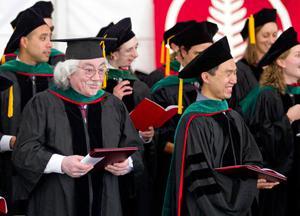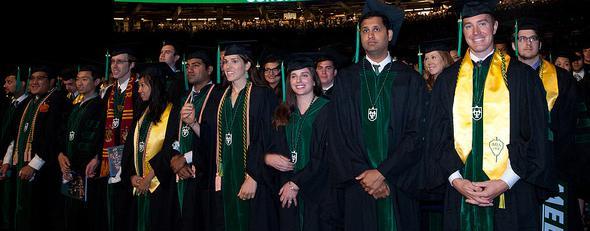The first image is the image on the left, the second image is the image on the right. Evaluate the accuracy of this statement regarding the images: "In one image, graduates are walking forward wearing black robes with green sleeve stripes and caps with green tassles.". Is it true? Answer yes or no. No. The first image is the image on the left, the second image is the image on the right. Examine the images to the left and right. Is the description "Blue seats are shown in the auditorium behind the graduates in one of the images." accurate? Answer yes or no. No. 